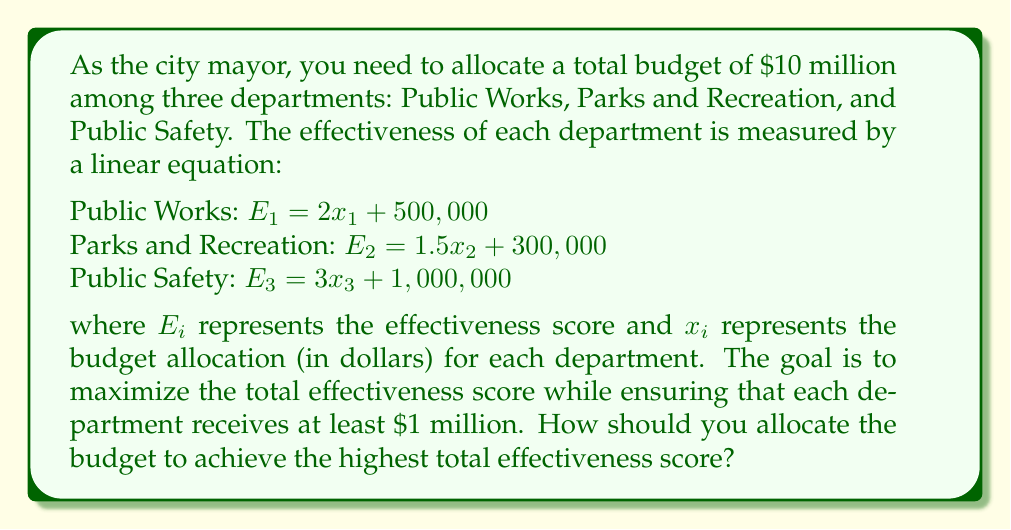Can you answer this question? Let's approach this step-by-step:

1) First, we need to set up our constraints:
   $x_1 + x_2 + x_3 = 10,000,000$ (total budget)
   $x_1 \geq 1,000,000$, $x_2 \geq 1,000,000$, $x_3 \geq 1,000,000$ (minimum allocations)

2) Our objective function is the sum of the effectiveness scores:
   $E_{total} = E_1 + E_2 + E_3 = (2x_1 + 500,000) + (1.5x_2 + 300,000) + (3x_3 + 1,000,000)$
   $E_{total} = 2x_1 + 1.5x_2 + 3x_3 + 1,800,000$

3) To maximize $E_{total}$, we need to allocate more money to the department with the highest coefficient in the effectiveness equation, which is Public Safety (coefficient of 3).

4) After ensuring the minimum $1 million for each department, we have $7 million left to allocate:
   $10,000,000 - (1,000,000 + 1,000,000 + 1,000,000) = 7,000,000$

5) We should allocate all of this remaining $7 million to Public Safety:
   $x_3 = 1,000,000 + 7,000,000 = 8,000,000$
   $x_1 = x_2 = 1,000,000$

6) Let's verify the total budget:
   $1,000,000 + 1,000,000 + 8,000,000 = 10,000,000$

7) Now we can calculate the total effectiveness score:
   $E_{total} = (2 * 1,000,000 + 500,000) + (1.5 * 1,000,000 + 300,000) + (3 * 8,000,000 + 1,000,000)$
               $= 2,500,000 + 1,800,000 + 25,000,000$
               $= 29,300,000$

Therefore, the optimal allocation is $1 million to Public Works, $1 million to Parks and Recreation, and $8 million to Public Safety, resulting in a total effectiveness score of 29,300,000.
Answer: Public Works: $1,000,000, Parks and Recreation: $1,000,000, Public Safety: $8,000,000 